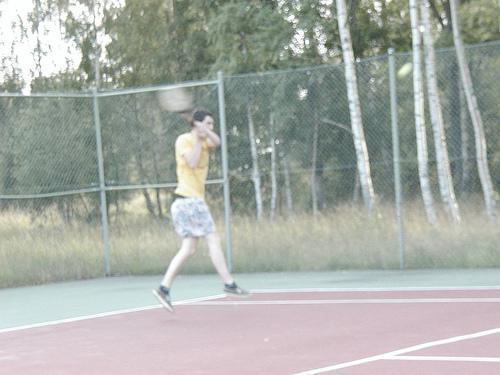How many people are shown?
Give a very brief answer. 1. 